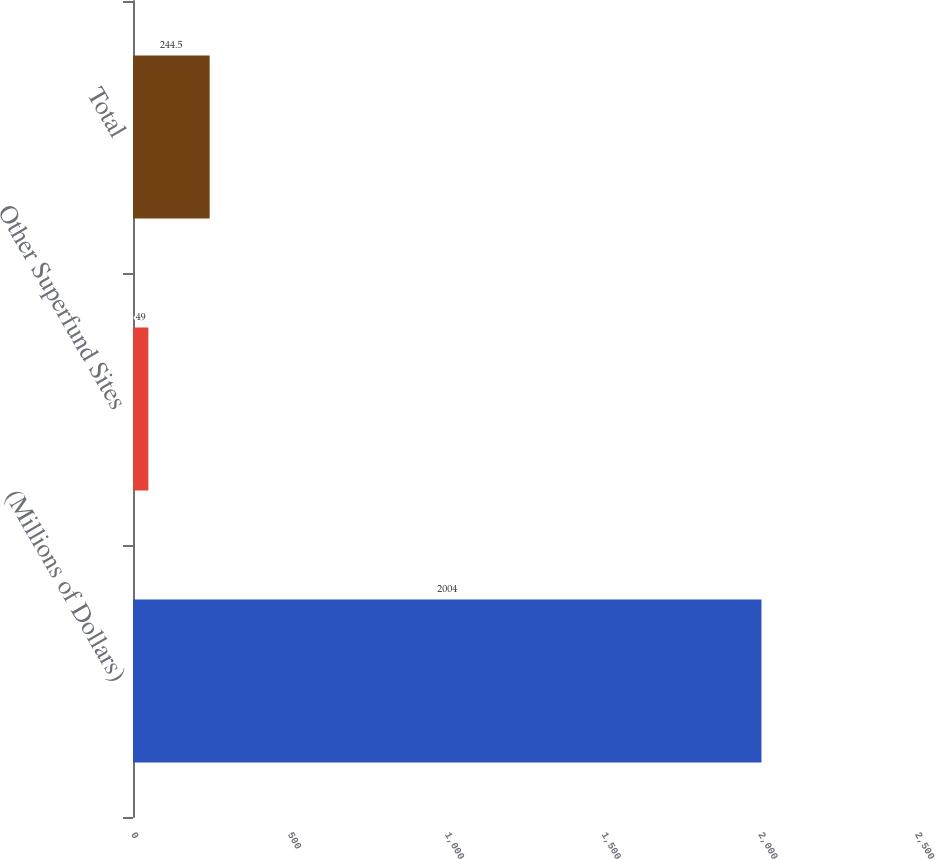<chart> <loc_0><loc_0><loc_500><loc_500><bar_chart><fcel>(Millions of Dollars)<fcel>Other Superfund Sites<fcel>Total<nl><fcel>2004<fcel>49<fcel>244.5<nl></chart> 